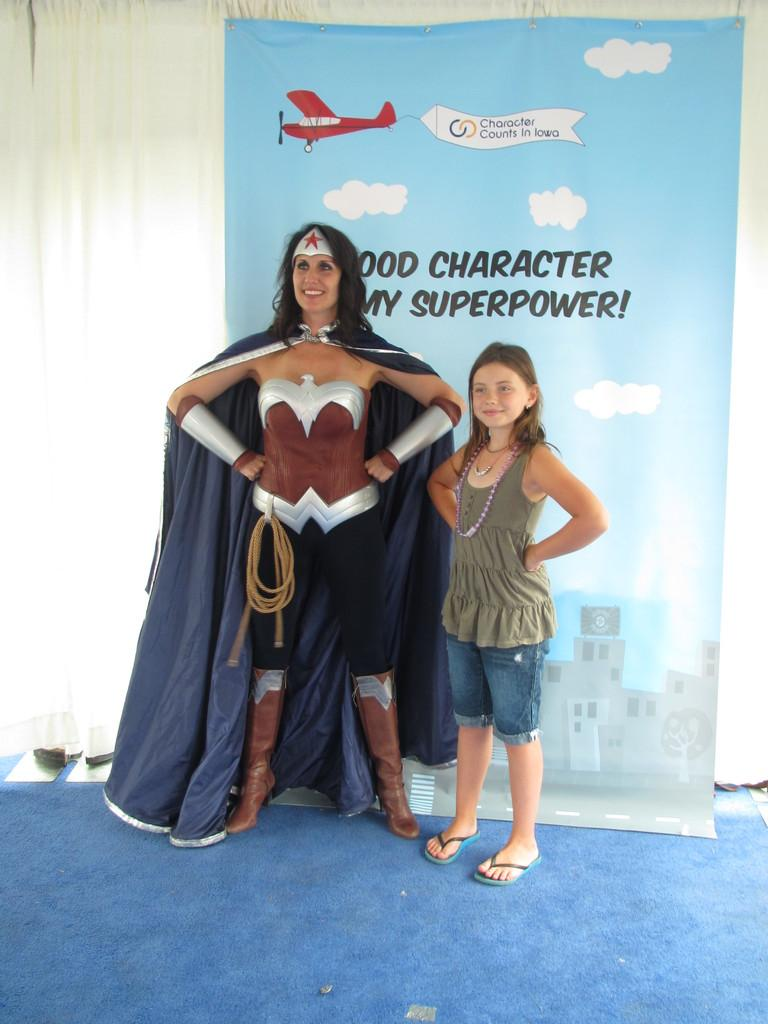<image>
Render a clear and concise summary of the photo. A woman in a super hero costume standing next to a girl with superpower over her head. 